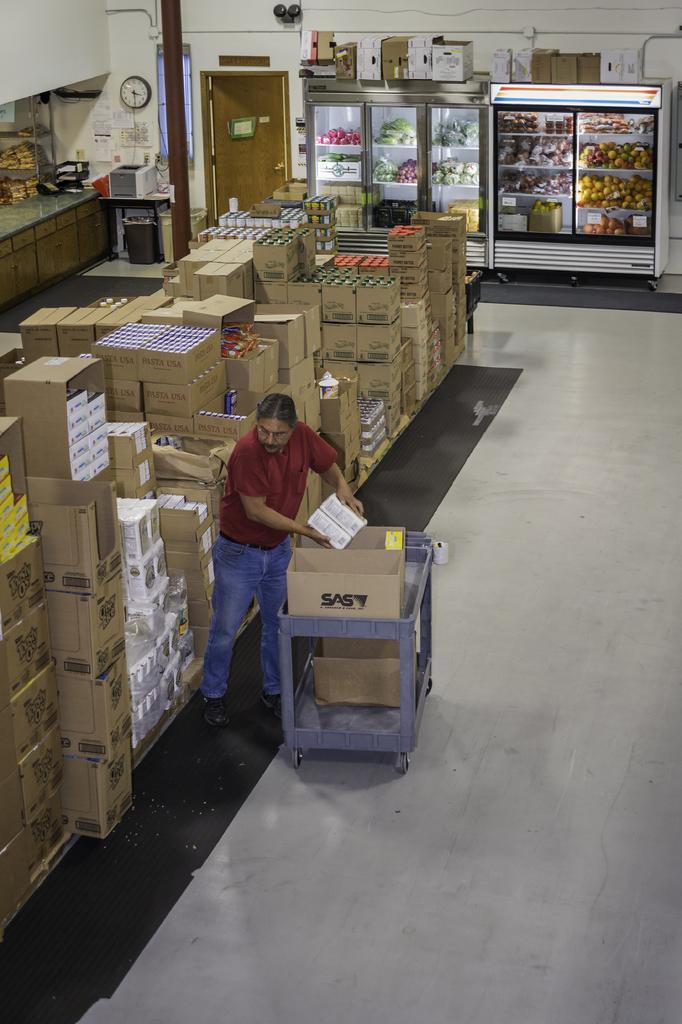Could you give a brief overview of what you see in this image? Here in this picture we can see a person standing on the floor over there and beside him on the right side we can see a trolley, on which we can see cardboard boxes with something present in it over there and he is removing something from those and keeping it on left side and we can see number of cardboard boxes present on the left side over there and at the top we can see fridges, which are fully covered with vegetable and meat present all over there and we can also see a clock on the wall over there and we can see a door in the middle and we can see other items present here and there on the floor over there. 